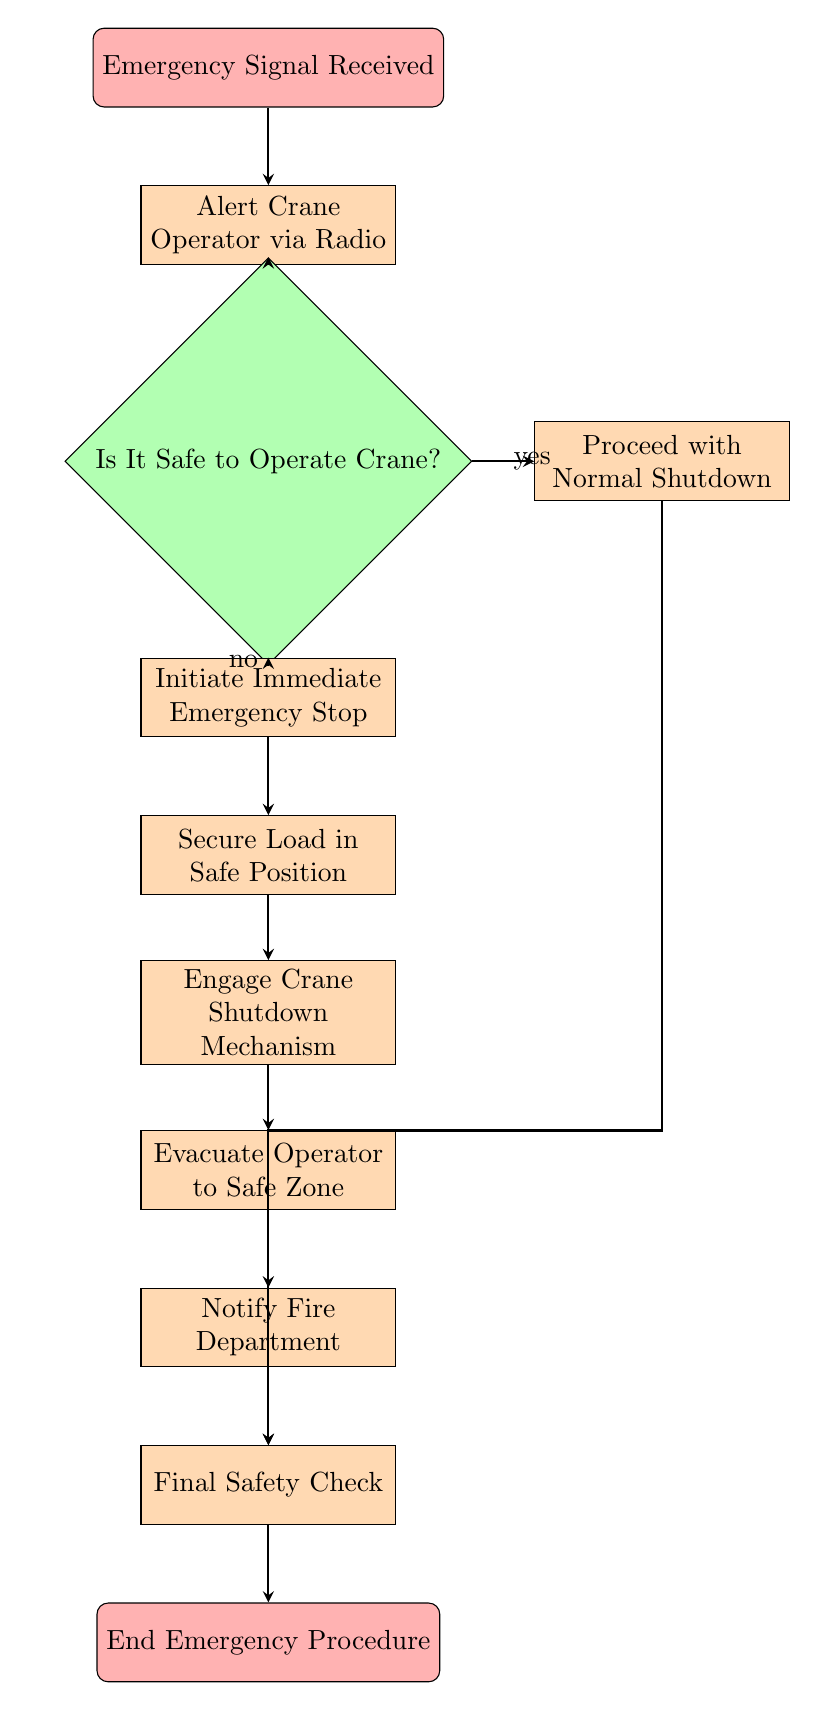What is the first step in the process? The first node in the flow chart is labeled "Emergency Signal Received," indicating the beginning of the safe shutdown process.
Answer: Emergency Signal Received How many total process nodes are in the diagram? The process nodes are "Alert Crane Operator via Radio," "Proceed with Normal Shutdown," "Initiate Immediate Emergency Stop," "Secure Load in Safe Position," "Engage Crane Shutdown Mechanism," "Evacuate Operator to Safe Zone," "Notify Fire Department," and "Final Safety Check," leading to a total of eight process nodes.
Answer: 8 What action occurs if it is safe to operate the crane? If it is determined to be safe to operate the crane (indicated by "yes"), the next node to process is "Proceed with Normal Shutdown."
Answer: Proceed with Normal Shutdown What must happen before engaging the crane shutdown mechanism? Before engaging the crane shutdown mechanism, the load must first be secured in a safe position, as indicated by the flow from "Secure Load in Safe Position" to "Engage Crane Shutdown Mechanism."
Answer: Secure Load in Safe Position Which node leads to notifying the fire department? The process node labeled "Notify Fire Department" follows the node "Evacuate Operator to Safe Zone," meaning this is the node that leads to notifying the fire department.
Answer: Notify Fire Department What happens if the operator identifies it is not safe to operate the crane? If it is identified that it is not safe to operate the crane (indicated by "no"), the process moves to the node "Initiate Immediate Emergency Stop," indicating an immediate response to the unsafe condition.
Answer: Initiate Immediate Emergency Stop What is the relationship between "Final Safety Check" and "End Emergency Procedure"? The node "Final Safety Check" directly leads to the final node "End Emergency Procedure," showing that the check is the last step before concluding the emergency procedure.
Answer: Final Safety Check What is the last process before evacuating the operator? The last process before the evacuation of the operator is to engage the crane shutdown mechanism, as indicated by the flow from "Engage Crane Shutdown Mechanism" to "Evacuate Operator to Safe Zone."
Answer: Engage Crane Shutdown Mechanism 